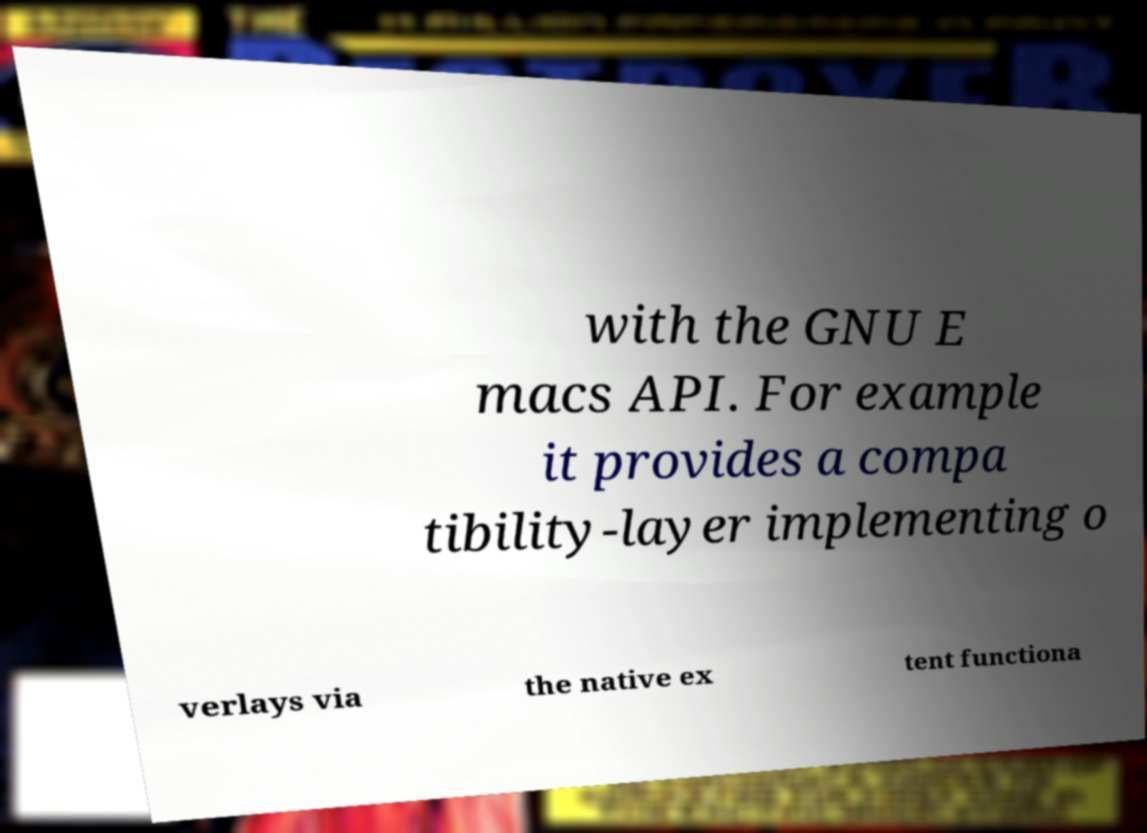There's text embedded in this image that I need extracted. Can you transcribe it verbatim? with the GNU E macs API. For example it provides a compa tibility-layer implementing o verlays via the native ex tent functiona 